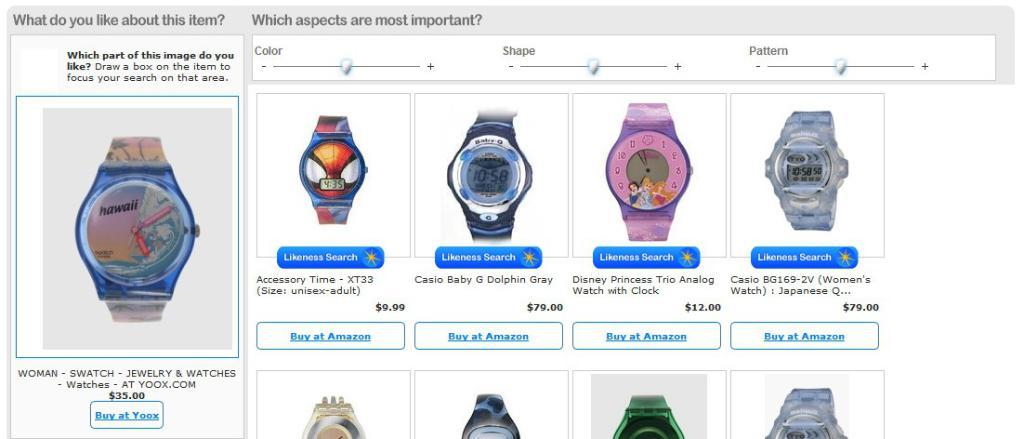Provide a one-sentence caption for the provided image. A set of watches are on display and a button is beneath them that says Buy at Amazon. 